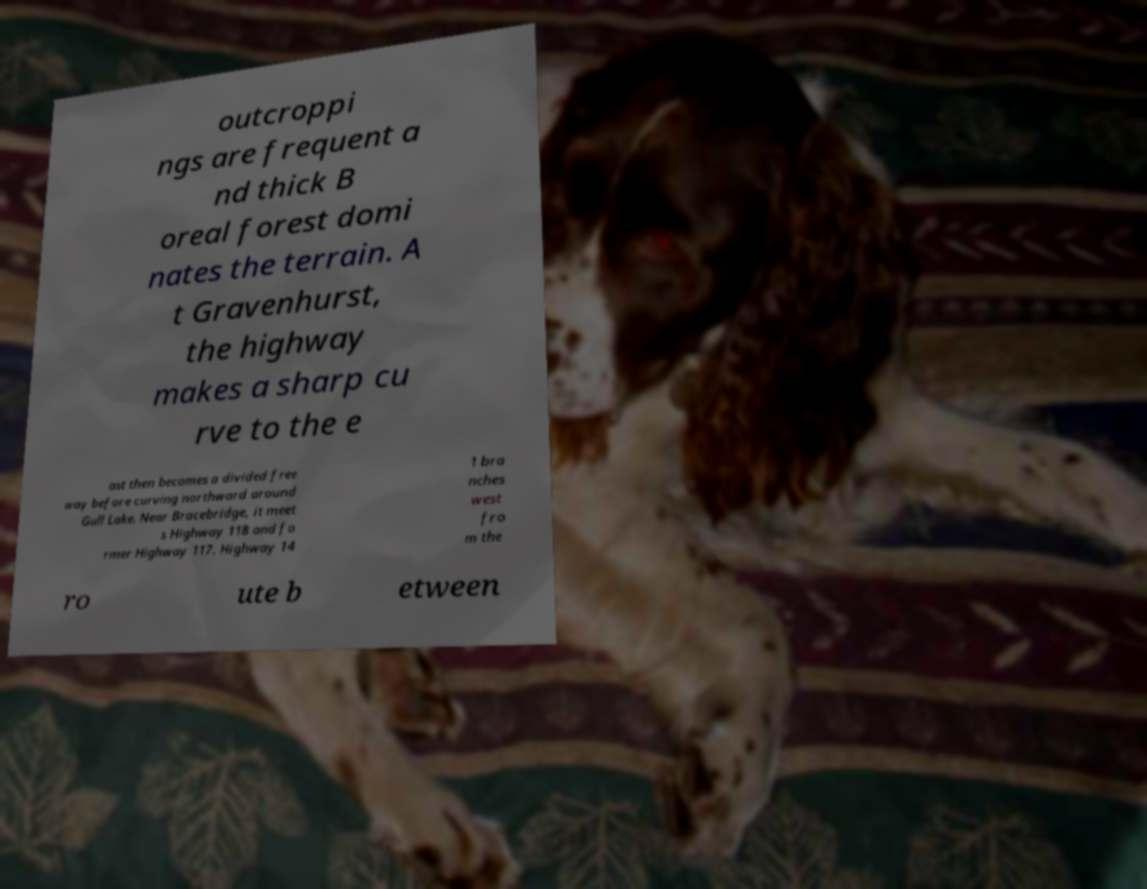Please identify and transcribe the text found in this image. outcroppi ngs are frequent a nd thick B oreal forest domi nates the terrain. A t Gravenhurst, the highway makes a sharp cu rve to the e ast then becomes a divided free way before curving northward around Gull Lake. Near Bracebridge, it meet s Highway 118 and fo rmer Highway 117. Highway 14 1 bra nches west fro m the ro ute b etween 